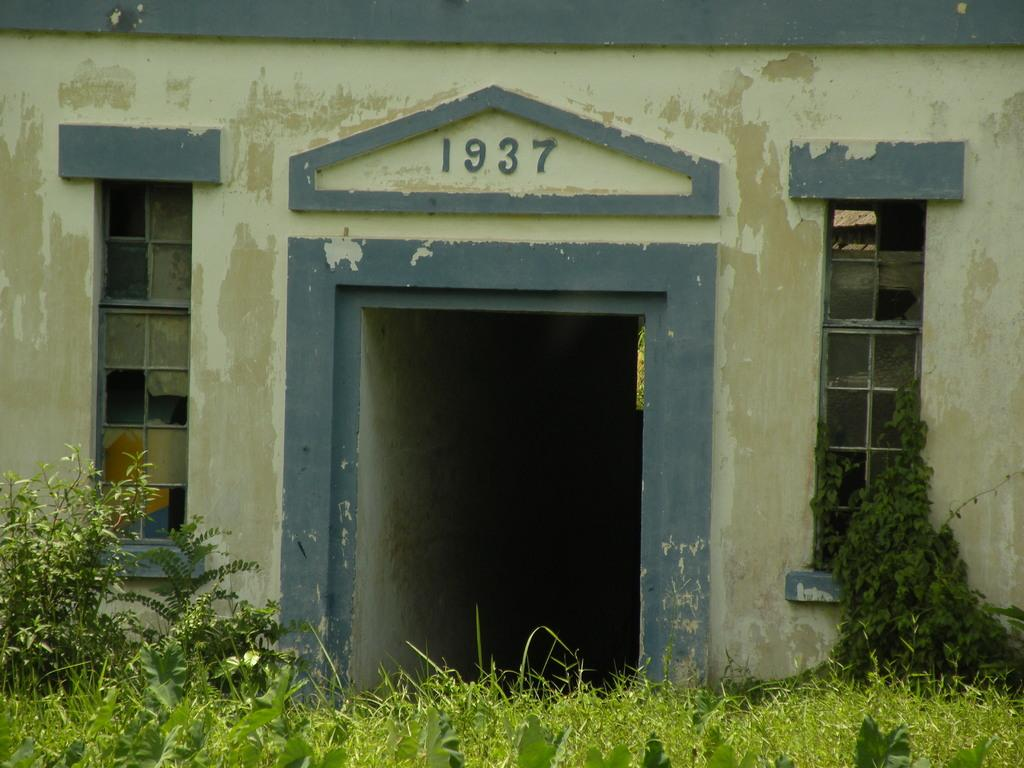What is the main subject of the picture? The main subject of the picture is a house. Can you describe any specific details about the house? Yes, there is writing on the house. What can be seen in the front of the image? There are plants and other objects in the front of the image. What type of exchange is taking place between the father and the house in the image? There is no father or exchange present in the image; it features a house with writing on it and plants in the front. 